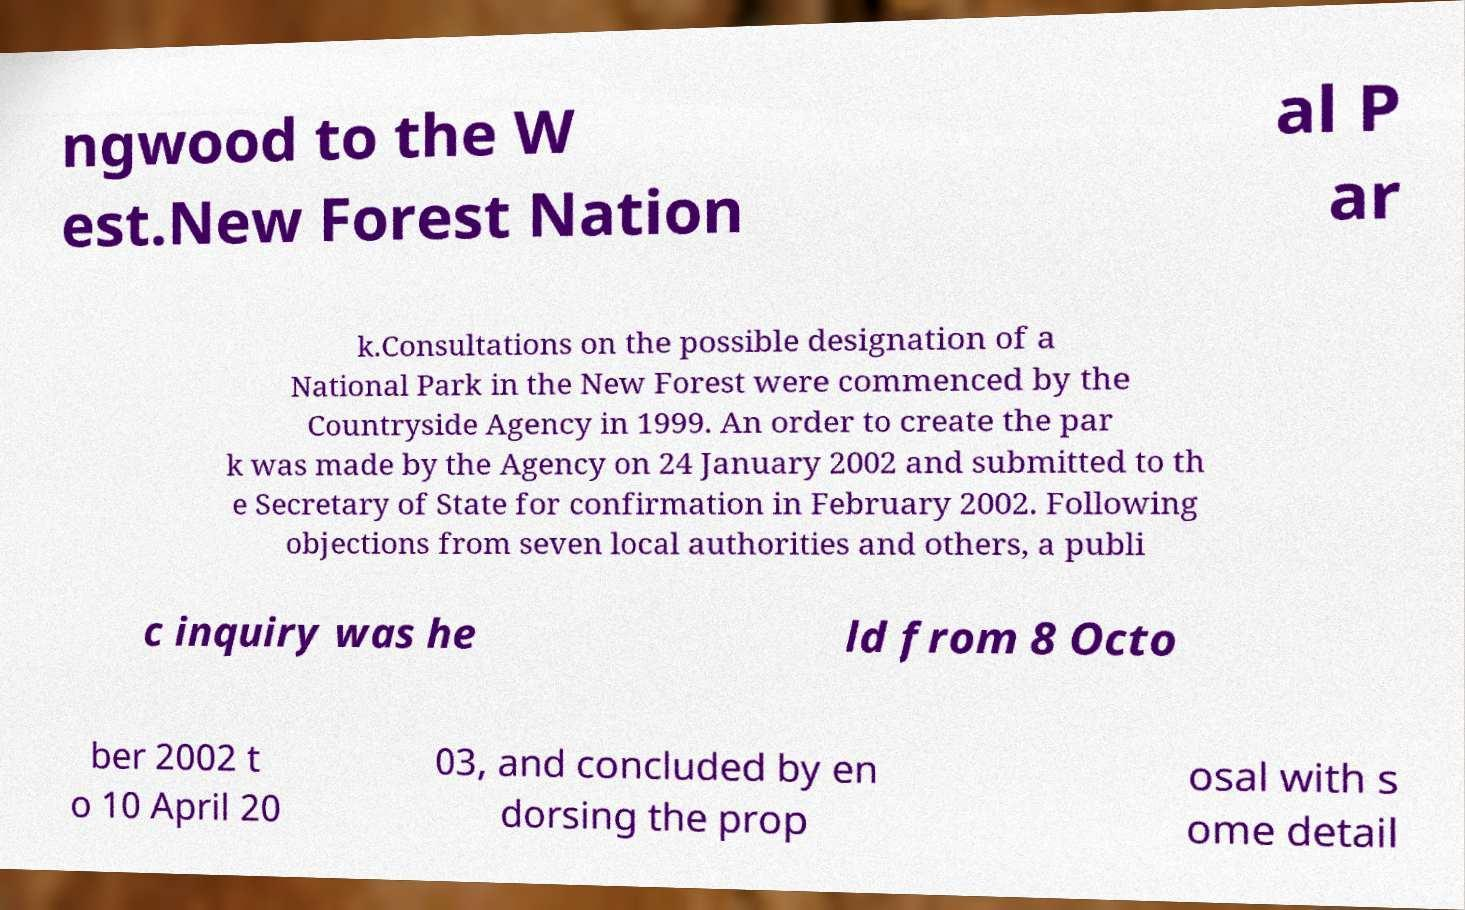Please read and relay the text visible in this image. What does it say? ngwood to the W est.New Forest Nation al P ar k.Consultations on the possible designation of a National Park in the New Forest were commenced by the Countryside Agency in 1999. An order to create the par k was made by the Agency on 24 January 2002 and submitted to th e Secretary of State for confirmation in February 2002. Following objections from seven local authorities and others, a publi c inquiry was he ld from 8 Octo ber 2002 t o 10 April 20 03, and concluded by en dorsing the prop osal with s ome detail 